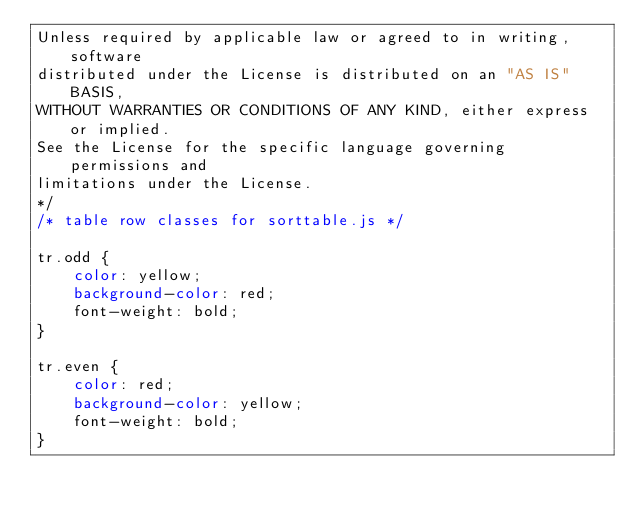<code> <loc_0><loc_0><loc_500><loc_500><_CSS_>Unless required by applicable law or agreed to in writing, software
distributed under the License is distributed on an "AS IS" BASIS,
WITHOUT WARRANTIES OR CONDITIONS OF ANY KIND, either express or implied.
See the License for the specific language governing permissions and
limitations under the License.
*/
/* table row classes for sorttable.js */

tr.odd {
    color: yellow;
    background-color: red;
    font-weight: bold;
}

tr.even {
    color: red;
    background-color: yellow;
    font-weight: bold;
}
</code> 